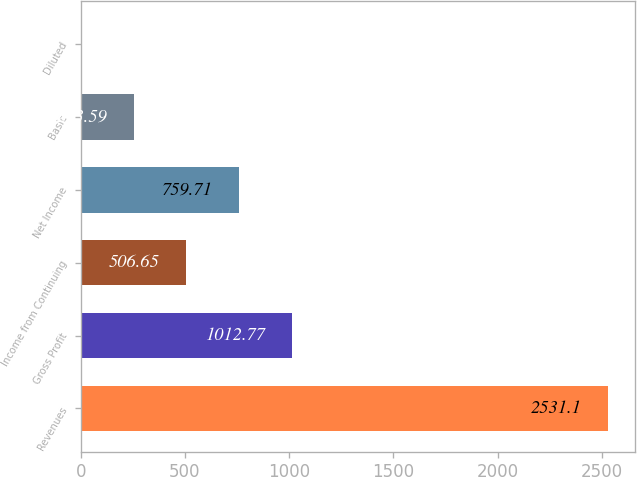<chart> <loc_0><loc_0><loc_500><loc_500><bar_chart><fcel>Revenues<fcel>Gross Profit<fcel>Income from Continuing<fcel>Net Income<fcel>Basic<fcel>Diluted<nl><fcel>2531.1<fcel>1012.77<fcel>506.65<fcel>759.71<fcel>253.59<fcel>0.53<nl></chart> 